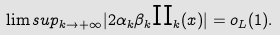Convert formula to latex. <formula><loc_0><loc_0><loc_500><loc_500>\lim s u p _ { k \rightarrow + \infty } | 2 \alpha _ { k } \beta _ { k } \text {II} _ { k } ( x ) | = o _ { L } ( 1 ) .</formula> 